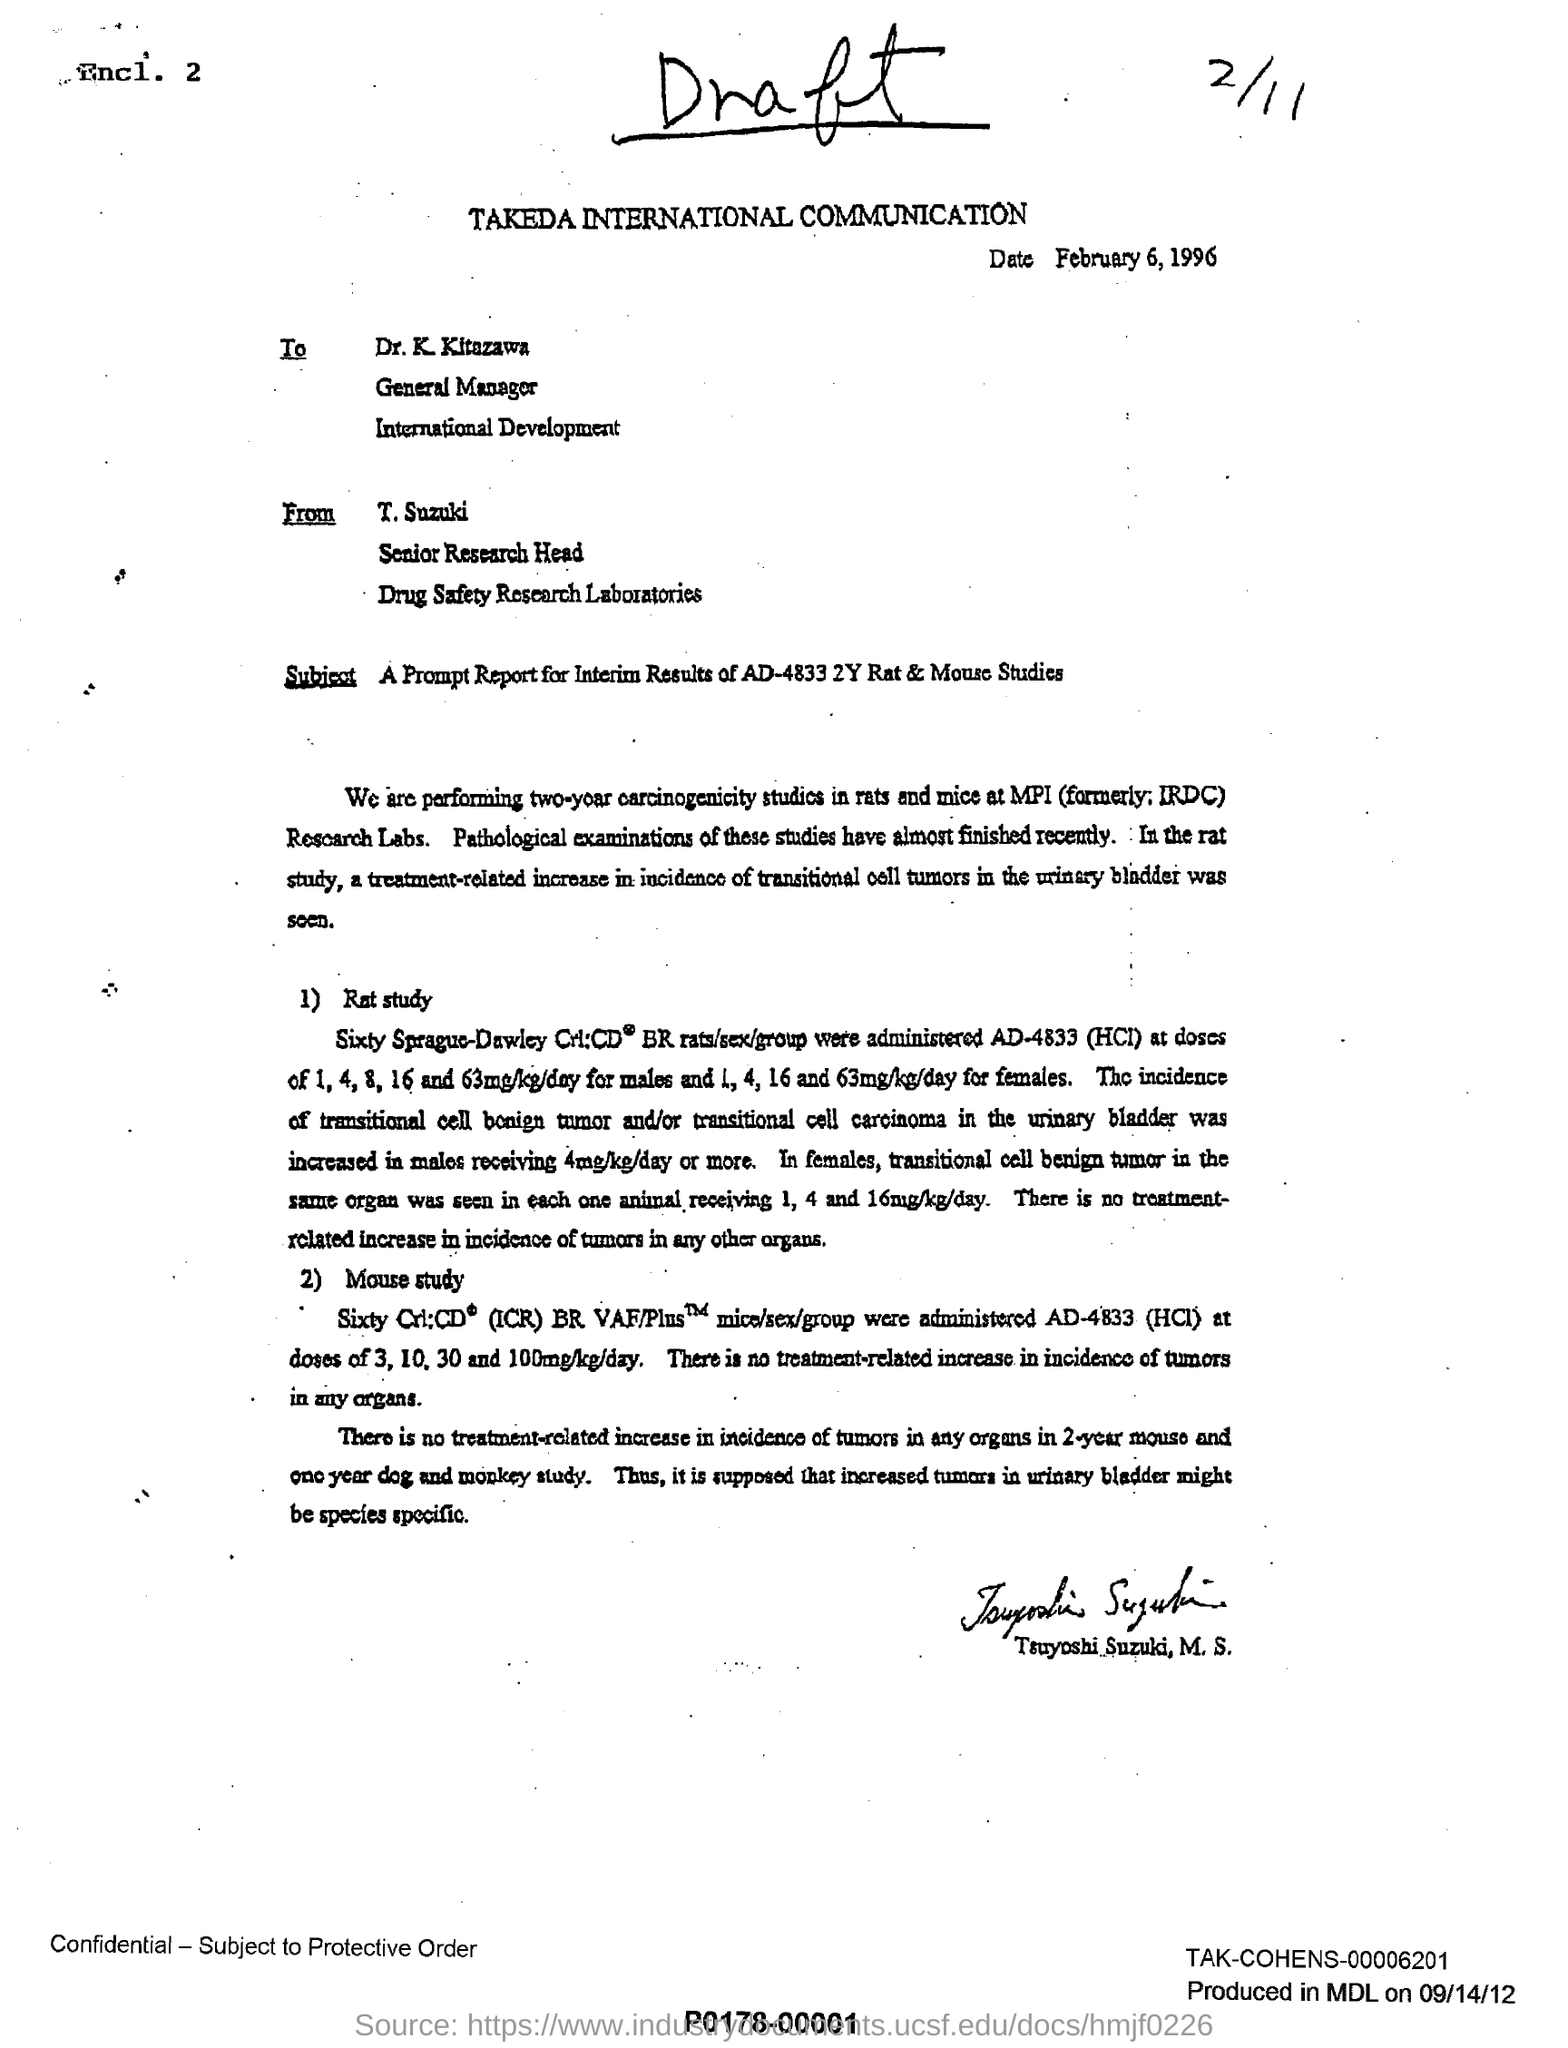What is the date mentioned ?
Make the answer very short. February 6 , 1996. To whom this letter is written  ?
Provide a succinct answer. Dr. K. KItazawa. This letter is written by whom ?
Make the answer very short. T. Suzuki. Which laboratory is T. Suzuki associated with ?
Offer a very short reply. Drug safety research laboratories . 